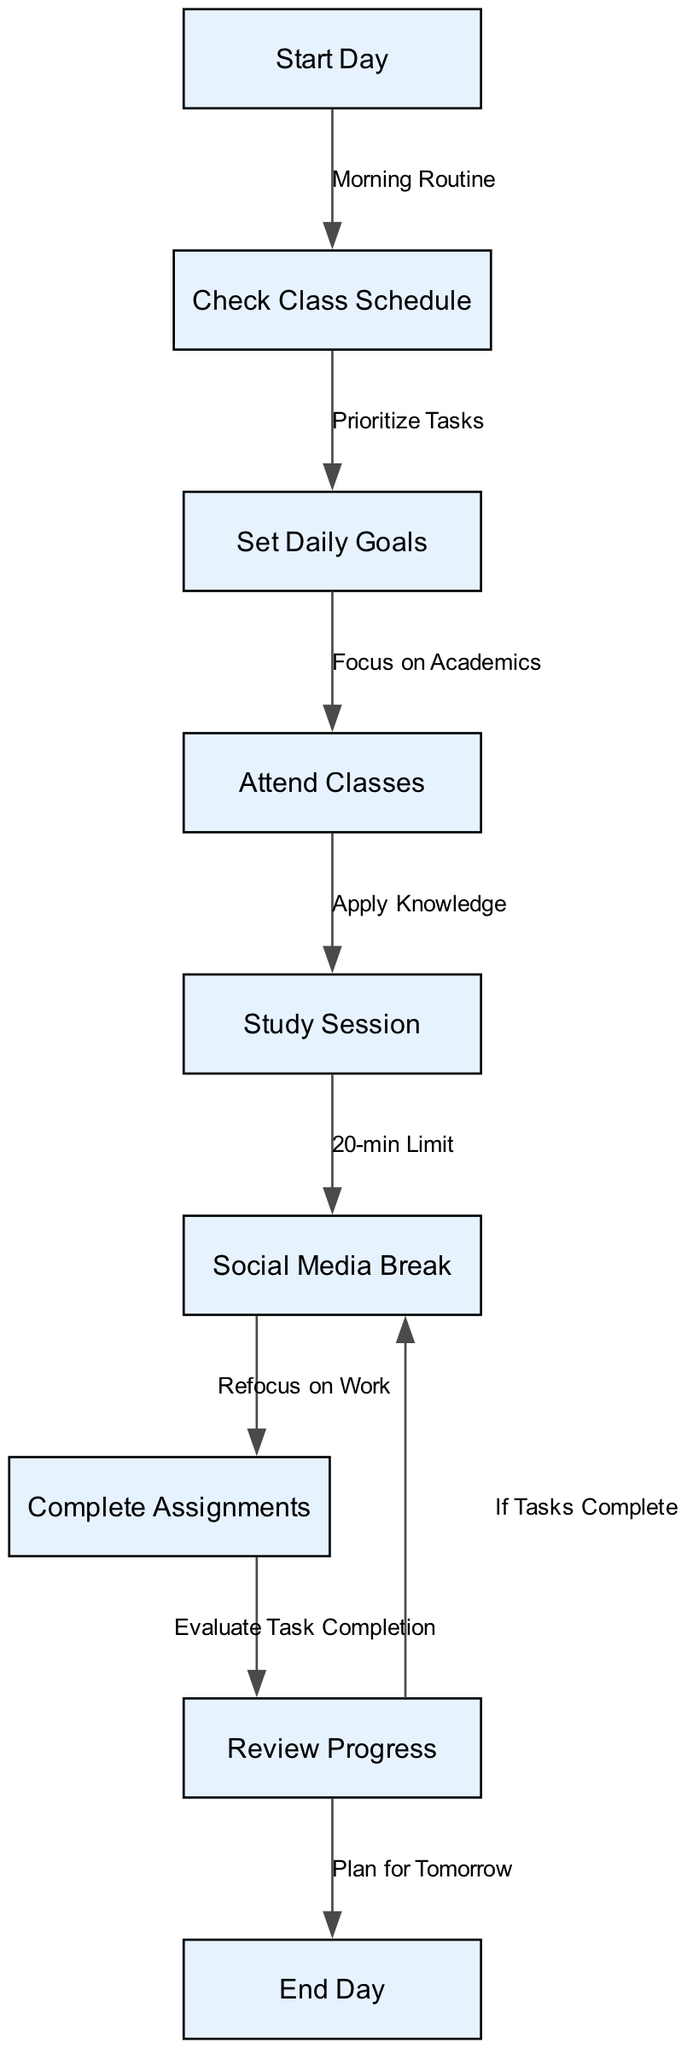What is the first node in the diagram? The first node in the diagram is labeled "Start Day." It is the starting point which signifies the beginning of the time management process outlined in the flowchart.
Answer: Start Day How many nodes are in the diagram? To determine the number of nodes, we count the entries listed in the "nodes" section of the data. There are nine nodes total.
Answer: 9 What is the label of the node before "Complete Assignments"? The node directly before "Complete Assignments" is labeled "Social Media Break." This means that after a social media break, one is expected to refocus on work and complete assignments.
Answer: Social Media Break Which node follows "Check Class Schedule"? The node that follows "Check Class Schedule" is labeled "Set Daily Goals," indicating that after checking the class schedule, the next step is to establish goals for the day.
Answer: Set Daily Goals What action is taken after the "Study Session"? After the "Study Session," the action taken is "Social Media Break," suggesting a brief pause to engage in social media for 20 minutes before returning to work.
Answer: Social Media Break If tasks are completed, where does the flow go next? If tasks are completed, the flow goes back to "Social Media Break." This indicates that once assignments are finished, one is allowed to take another break for social media.
Answer: Social Media Break What is a prerequisite for attending classes? A prerequisite for attending classes is "Set Daily Goals." This shows that goal setting is essential before proceeding to attend academic classes.
Answer: Set Daily Goals What is the last step in the flowchart? The last step in the flowchart is "End Day." This signifies the conclusion of the daily time management process after reviewing the day's progress.
Answer: End Day Describe the relationship between "Attend Classes" and "Study Session." The relationship between "Attend Classes" and "Study Session" is sequential, as "Attend Classes" must occur before one can proceed to the "Study Session," indicating the flow of knowledge application.
Answer: Apply Knowledge 